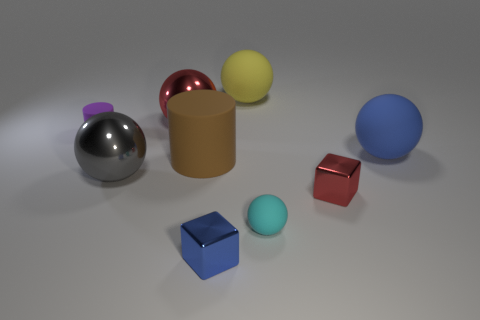Subtract all red shiny balls. How many balls are left? 4 Subtract all yellow spheres. How many spheres are left? 4 Subtract all green spheres. Subtract all gray cylinders. How many spheres are left? 5 Add 1 blue shiny blocks. How many objects exist? 10 Subtract all balls. How many objects are left? 4 Add 6 cyan things. How many cyan things are left? 7 Add 9 big gray rubber blocks. How many big gray rubber blocks exist? 9 Subtract 1 blue cubes. How many objects are left? 8 Subtract all tiny cylinders. Subtract all metal balls. How many objects are left? 6 